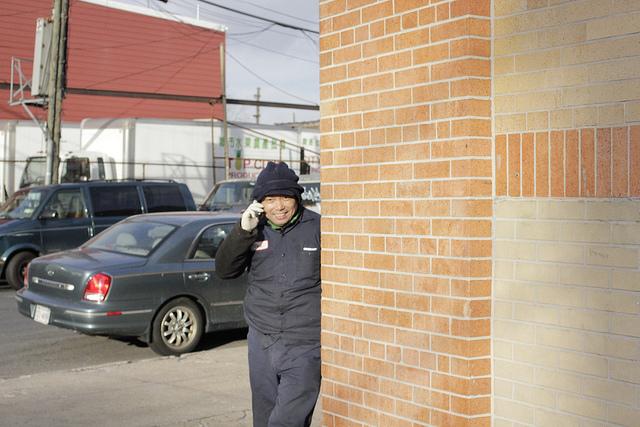Was this picture taken in a mirror?
Write a very short answer. No. What is this man holding?
Be succinct. Phone. What is the man doing?
Keep it brief. Talking on phone. How many cars can be seen?
Give a very brief answer. 3. 